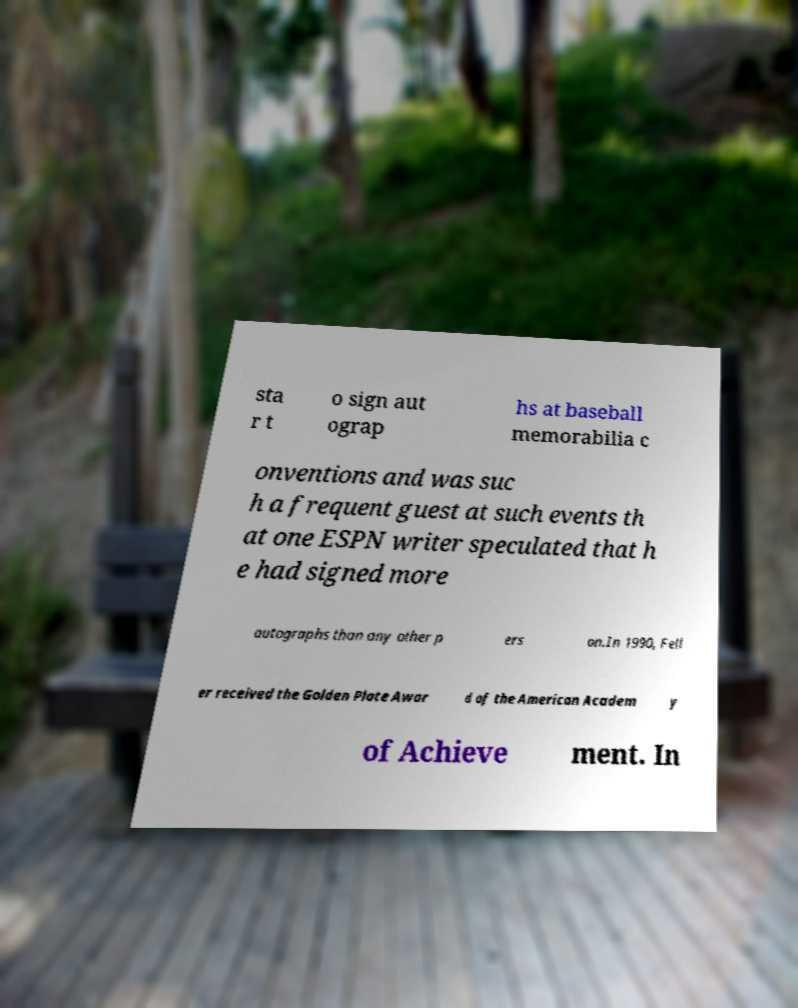Could you assist in decoding the text presented in this image and type it out clearly? sta r t o sign aut ograp hs at baseball memorabilia c onventions and was suc h a frequent guest at such events th at one ESPN writer speculated that h e had signed more autographs than any other p ers on.In 1990, Fell er received the Golden Plate Awar d of the American Academ y of Achieve ment. In 